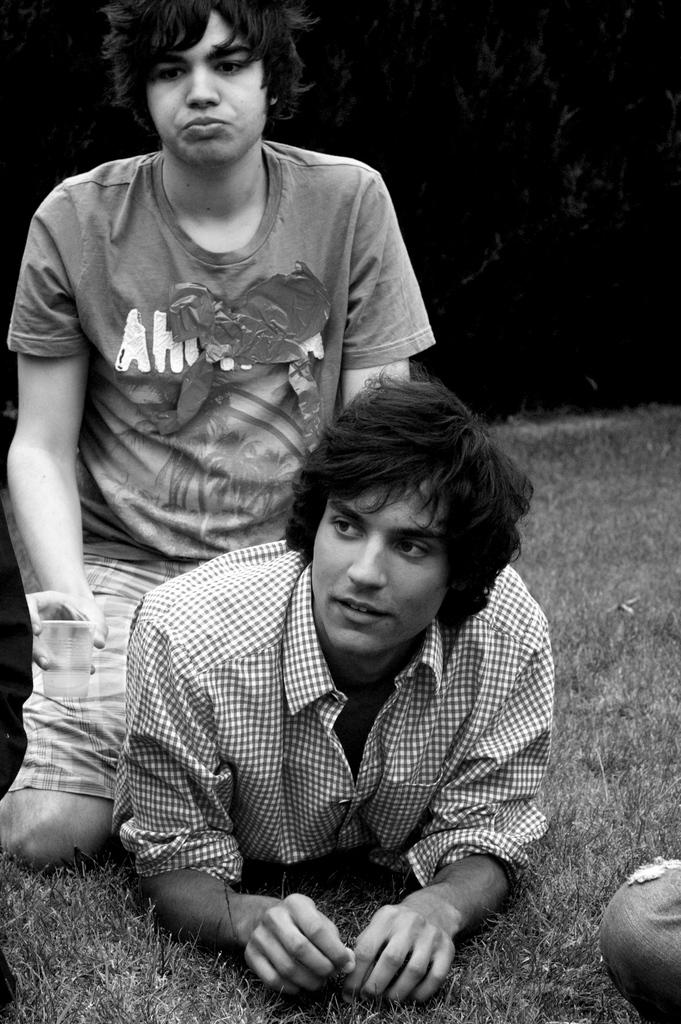How many people are in the image? There are two persons in the image. What type of surface is visible in the image? There is grass in the image. Can you describe the position of one of the persons in the image? A leg of a person is visible in the bottom right corner of the image. What is the color of the background in the image? The background of the image is dark. What type of roof can be seen in the image? There is no roof visible in the image. Is there a hose being used by one of the persons in the image? There is no hose present in the image. 